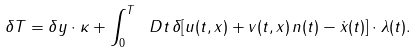Convert formula to latex. <formula><loc_0><loc_0><loc_500><loc_500>\delta T = \delta y \cdot \kappa + \int _ { 0 } ^ { T } \ D t \, \delta [ u ( t , x ) + v ( t , x ) \, n ( t ) - \dot { x } ( t ) ] \cdot \lambda ( t ) .</formula> 